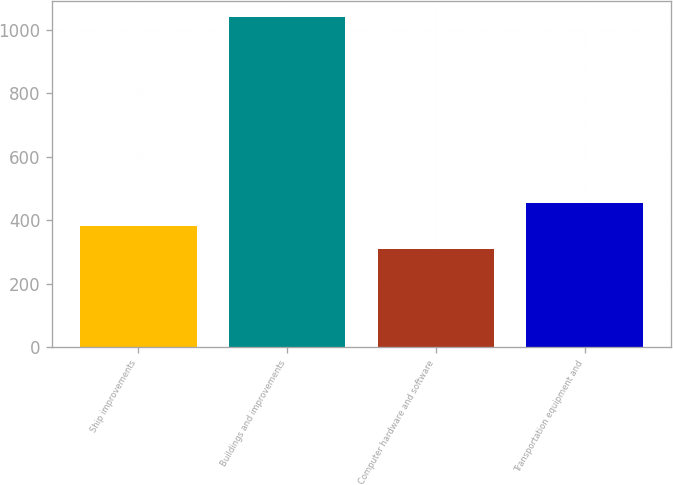<chart> <loc_0><loc_0><loc_500><loc_500><bar_chart><fcel>Ship improvements<fcel>Buildings and improvements<fcel>Computer hardware and software<fcel>Transportation equipment and<nl><fcel>383<fcel>1040<fcel>310<fcel>456<nl></chart> 